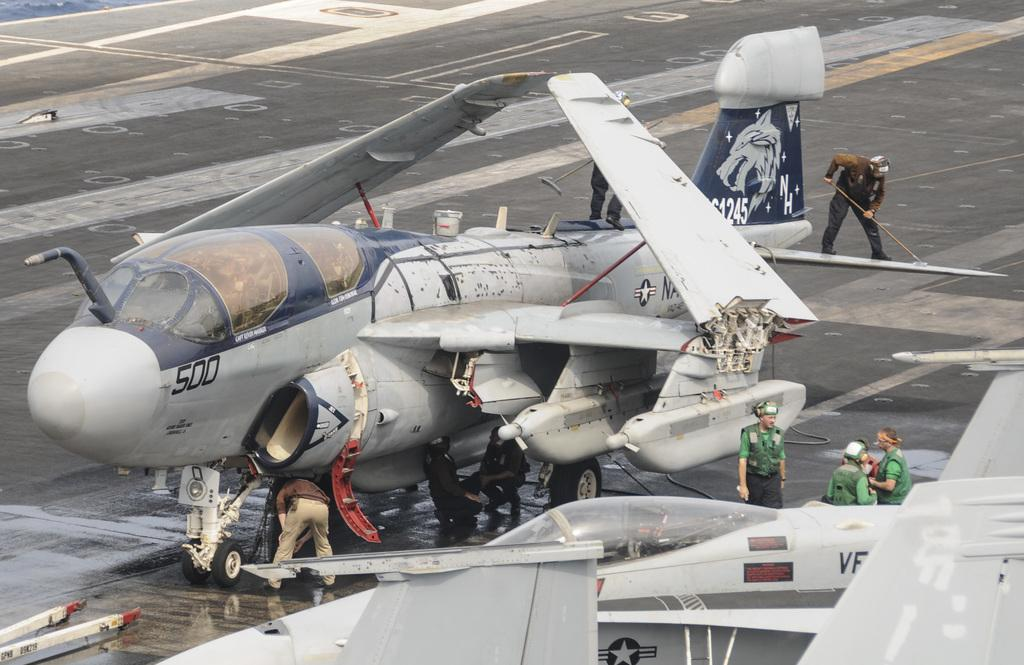<image>
Present a compact description of the photo's key features. Airplane number 500 sits on the runway and has several people working on it. 